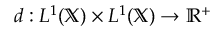<formula> <loc_0><loc_0><loc_500><loc_500>d \colon L ^ { 1 } ( \mathbb { X } ) \times L ^ { 1 } ( \mathbb { X } ) \rightarrow \mathbb { R } ^ { + }</formula> 